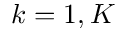<formula> <loc_0><loc_0><loc_500><loc_500>k = 1 , K</formula> 